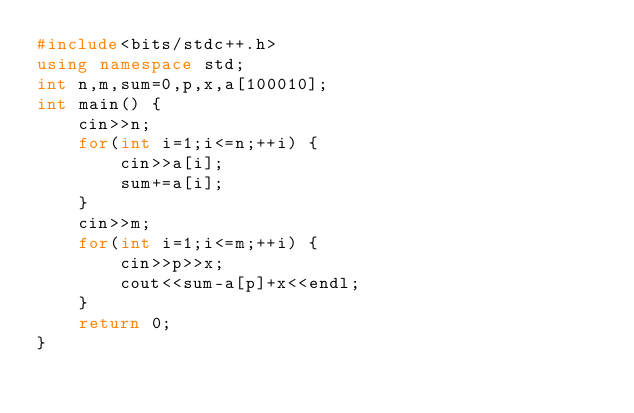Convert code to text. <code><loc_0><loc_0><loc_500><loc_500><_C++_>#include<bits/stdc++.h>
using namespace std;
int n,m,sum=0,p,x,a[100010];
int main() {
	cin>>n;
	for(int i=1;i<=n;++i) {
		cin>>a[i];
		sum+=a[i];
	}
	cin>>m;
	for(int i=1;i<=m;++i) {
		cin>>p>>x;
		cout<<sum-a[p]+x<<endl;
	}
	return 0;
}</code> 